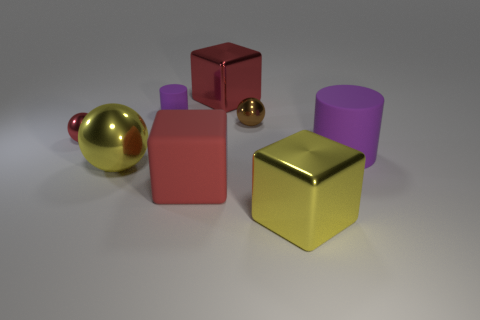Add 1 rubber cubes. How many objects exist? 9 Subtract all balls. How many objects are left? 5 Add 1 tiny yellow metallic cylinders. How many tiny yellow metallic cylinders exist? 1 Subtract 1 yellow cubes. How many objects are left? 7 Subtract all large red shiny blocks. Subtract all big rubber blocks. How many objects are left? 6 Add 1 red shiny spheres. How many red shiny spheres are left? 2 